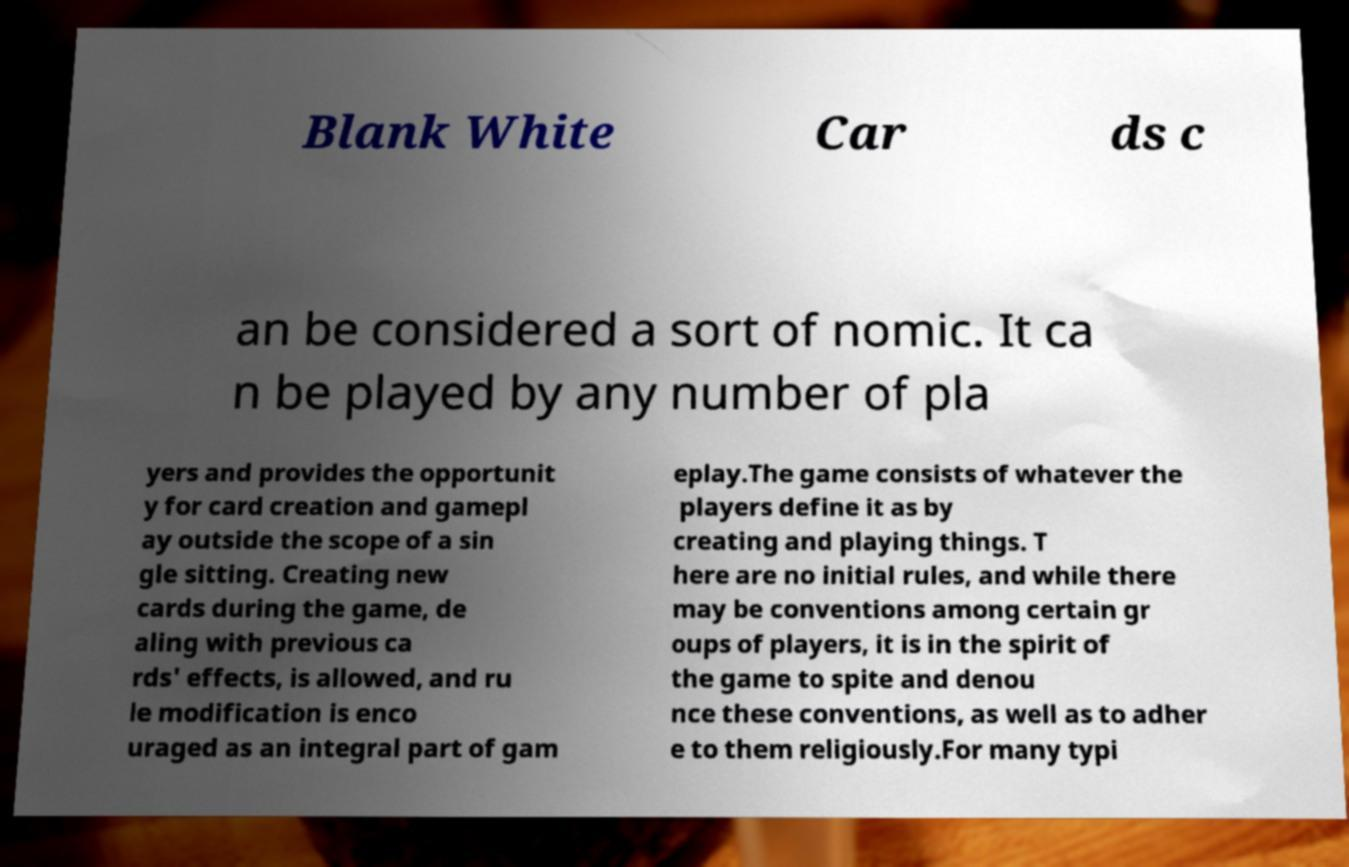I need the written content from this picture converted into text. Can you do that? Blank White Car ds c an be considered a sort of nomic. It ca n be played by any number of pla yers and provides the opportunit y for card creation and gamepl ay outside the scope of a sin gle sitting. Creating new cards during the game, de aling with previous ca rds' effects, is allowed, and ru le modification is enco uraged as an integral part of gam eplay.The game consists of whatever the players define it as by creating and playing things. T here are no initial rules, and while there may be conventions among certain gr oups of players, it is in the spirit of the game to spite and denou nce these conventions, as well as to adher e to them religiously.For many typi 